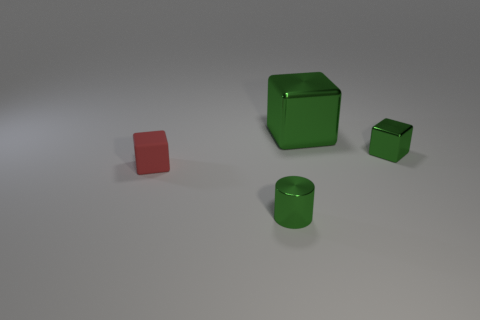Subtract all shiny blocks. How many blocks are left? 1 Add 3 big red shiny objects. How many objects exist? 7 Subtract all cubes. How many objects are left? 1 Add 4 tiny yellow matte cylinders. How many tiny yellow matte cylinders exist? 4 Subtract 0 cyan blocks. How many objects are left? 4 Subtract all matte objects. Subtract all green shiny objects. How many objects are left? 0 Add 3 blocks. How many blocks are left? 6 